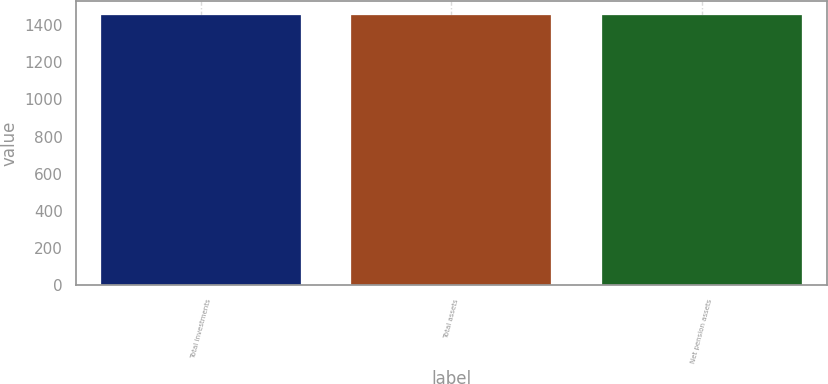Convert chart to OTSL. <chart><loc_0><loc_0><loc_500><loc_500><bar_chart><fcel>Total investments<fcel>Total assets<fcel>Net pension assets<nl><fcel>1454<fcel>1454.1<fcel>1454.2<nl></chart> 